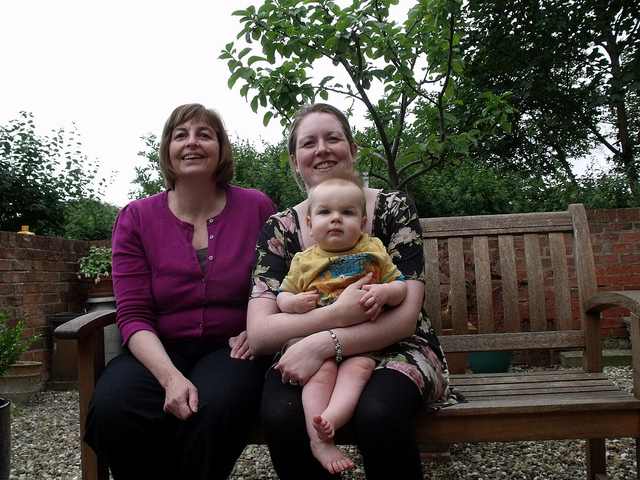<image>Is the older woman from this place? It is possible, but I can't say for sure if the older woman is from this place. Is the older woman from this place? I don't know if the older woman is from this place. It is possible that she is, but I can't say for sure. 